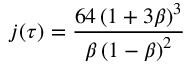Convert formula to latex. <formula><loc_0><loc_0><loc_500><loc_500>j ( \tau ) = { \frac { 6 4 \left ( 1 + 3 \beta \right ) ^ { 3 } } { \beta \left ( 1 - \beta \right ) ^ { 2 } } }</formula> 